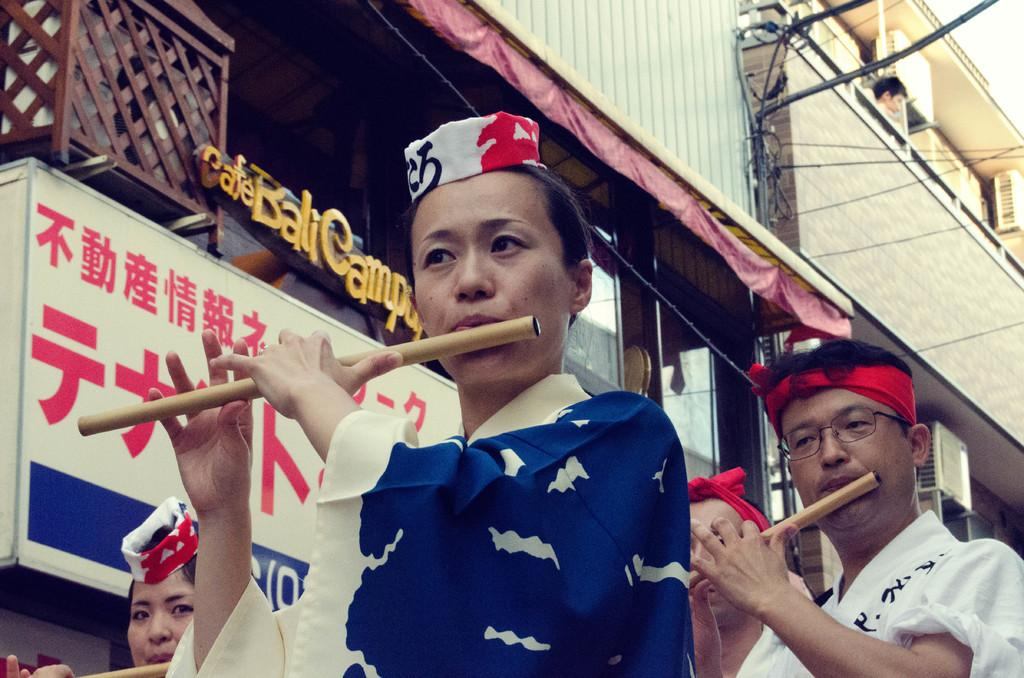What are the people in the image holding in their hands? The people in the image are holding flutes in their hands. What structure can be seen in the image? There is a building in the image. What type of soap is being used by the people in the image? There is no soap present in the image; the people are holding flutes. Is there a sofa visible in the image? There is no sofa present in the image. 